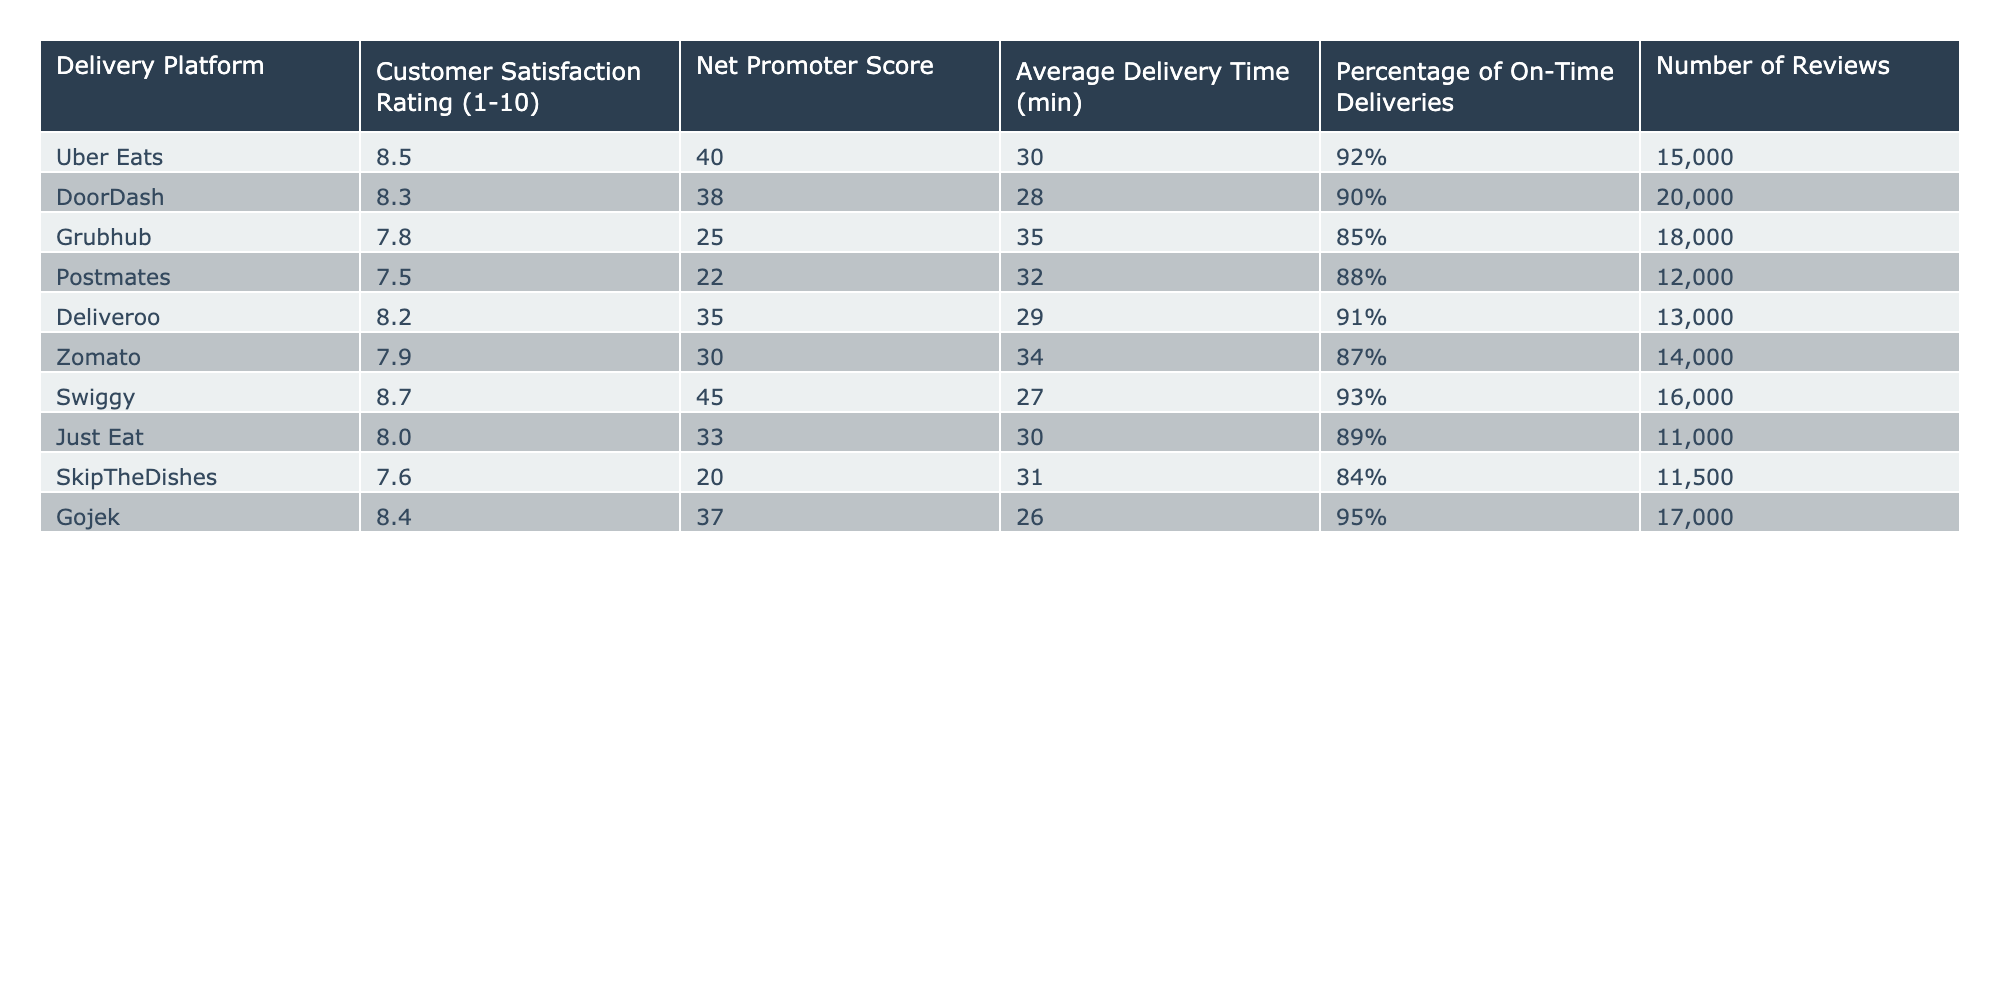What is the customer satisfaction rating of Swiggy? The table lists the customer satisfaction rating for Swiggy as 8.7.
Answer: 8.7 Which delivery platform has the highest Net Promoter Score? Swiggy has the highest Net Promoter Score at 45 according to the table.
Answer: Swiggy What is the average delivery time for DoorDash? The table indicates that the average delivery time for DoorDash is 28 minutes.
Answer: 28 minutes What delivery platform has the lowest customer satisfaction rating? The lowest customer satisfaction rating is for Grubhub, which is 7.8 according to the table.
Answer: Grubhub What is the percentage of on-time deliveries for Gojek? Gojek has a percentage of on-time deliveries at 95%, as shown in the table.
Answer: 95% If we compare Uber Eats and Grubhub, how much higher is Uber Eats' customer satisfaction rating? Uber Eats' rating is 8.5 and Grubhub's rating is 7.8. The difference is 8.5 - 7.8 = 0.7.
Answer: 0.7 What is the ratio of the highest customer satisfaction rating to the lowest customer satisfaction rating? The highest rating is 8.7 (Swiggy) and the lowest is 7.5 (Postmates). The ratio is 8.7:7.5, which simplifies to approximately 1.16:1.
Answer: 1.16:1 Does Just Eat have a higher average delivery time than Deliveroo? Just Eat has an average delivery time of 30 minutes while Deliveroo has 29 minutes. This means Just Eat does have a higher average delivery time.
Answer: Yes Which platform has the most reviews and what is the rating associated with it? DoorDash has the most reviews at 20,000 and its customer satisfaction rating is 8.3.
Answer: 8.3 Calculate the difference in the Net Promoter Scores between Swiggy and Grubhub. Swiggy has a Net Promoter Score of 45 and Grubhub has 25. The difference is 45 - 25 = 20.
Answer: 20 Which delivery platform has a customer satisfaction rating below 8? Both Grubhub and Postmates have ratings below 8, with Grubhub at 7.8 and Postmates at 7.5.
Answer: Grubhub, Postmates What is the combined percentage of on-time deliveries for the platforms rated 8.0 and above? The platforms rated 8.0 and above are Uber Eats, DoorDash, Deliveroo, Swiggy, and Gojek. Their on-time delivery percentages are 92%, 90%, 91%, 93%, and 95% respectively. Adding these gives 92 + 90 + 91 + 93 + 95 = 461%. The average is 461% / 5 = 92.2%.
Answer: 92.2% 